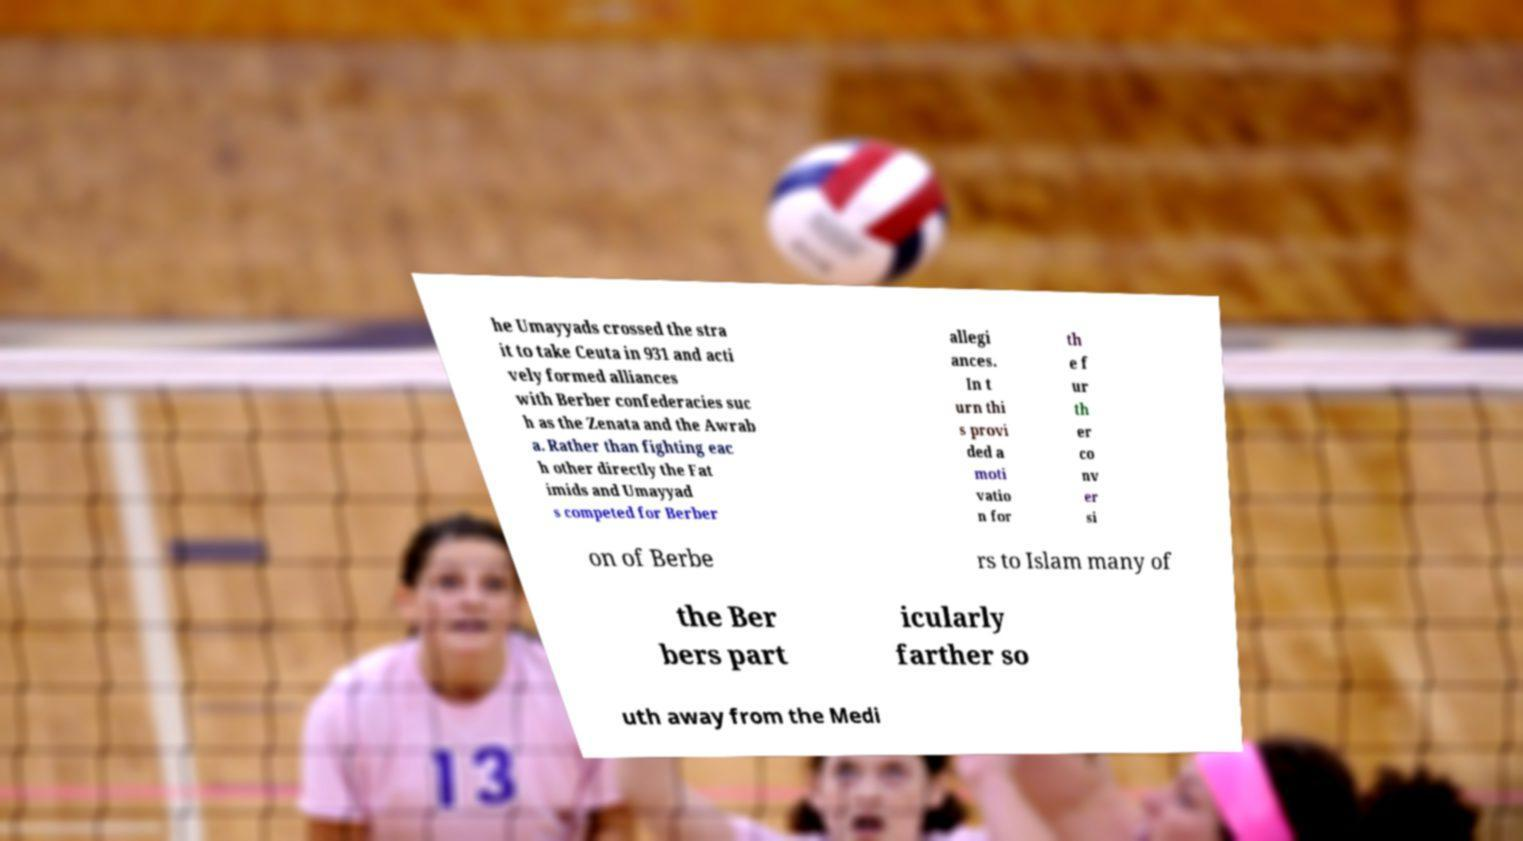For documentation purposes, I need the text within this image transcribed. Could you provide that? he Umayyads crossed the stra it to take Ceuta in 931 and acti vely formed alliances with Berber confederacies suc h as the Zenata and the Awrab a. Rather than fighting eac h other directly the Fat imids and Umayyad s competed for Berber allegi ances. In t urn thi s provi ded a moti vatio n for th e f ur th er co nv er si on of Berbe rs to Islam many of the Ber bers part icularly farther so uth away from the Medi 